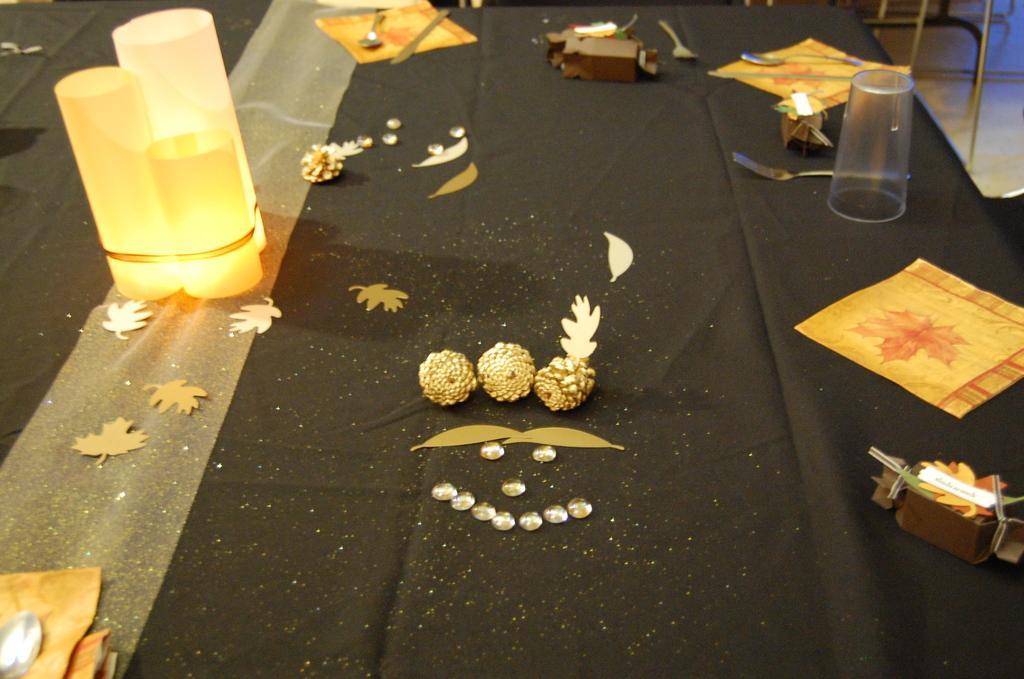In one or two sentences, can you explain what this image depicts? In this image, we can see lights, spoons, a glass, papers and some decor items are on the table. In the background, there are stands and there is a floor. 